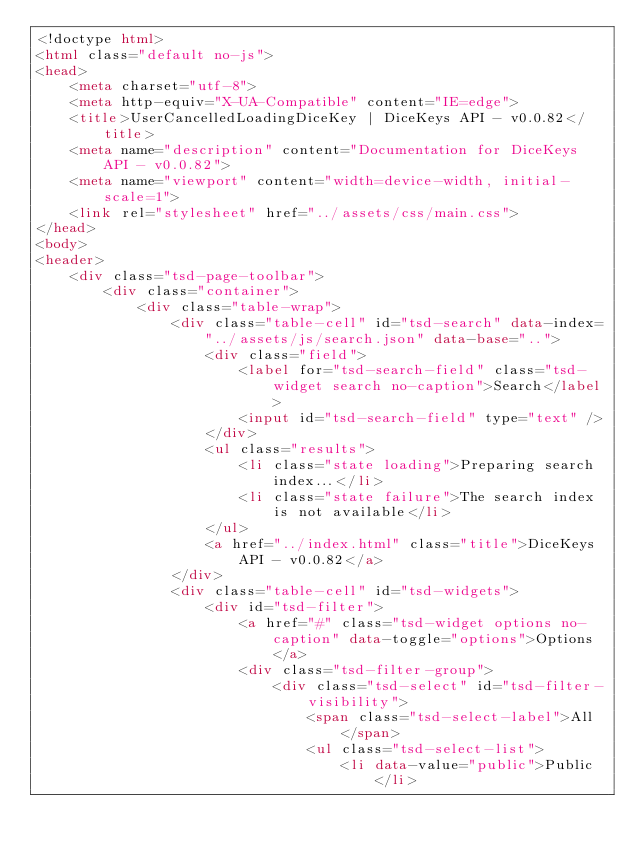Convert code to text. <code><loc_0><loc_0><loc_500><loc_500><_HTML_><!doctype html>
<html class="default no-js">
<head>
	<meta charset="utf-8">
	<meta http-equiv="X-UA-Compatible" content="IE=edge">
	<title>UserCancelledLoadingDiceKey | DiceKeys API - v0.0.82</title>
	<meta name="description" content="Documentation for DiceKeys API - v0.0.82">
	<meta name="viewport" content="width=device-width, initial-scale=1">
	<link rel="stylesheet" href="../assets/css/main.css">
</head>
<body>
<header>
	<div class="tsd-page-toolbar">
		<div class="container">
			<div class="table-wrap">
				<div class="table-cell" id="tsd-search" data-index="../assets/js/search.json" data-base="..">
					<div class="field">
						<label for="tsd-search-field" class="tsd-widget search no-caption">Search</label>
						<input id="tsd-search-field" type="text" />
					</div>
					<ul class="results">
						<li class="state loading">Preparing search index...</li>
						<li class="state failure">The search index is not available</li>
					</ul>
					<a href="../index.html" class="title">DiceKeys API - v0.0.82</a>
				</div>
				<div class="table-cell" id="tsd-widgets">
					<div id="tsd-filter">
						<a href="#" class="tsd-widget options no-caption" data-toggle="options">Options</a>
						<div class="tsd-filter-group">
							<div class="tsd-select" id="tsd-filter-visibility">
								<span class="tsd-select-label">All</span>
								<ul class="tsd-select-list">
									<li data-value="public">Public</li></code> 